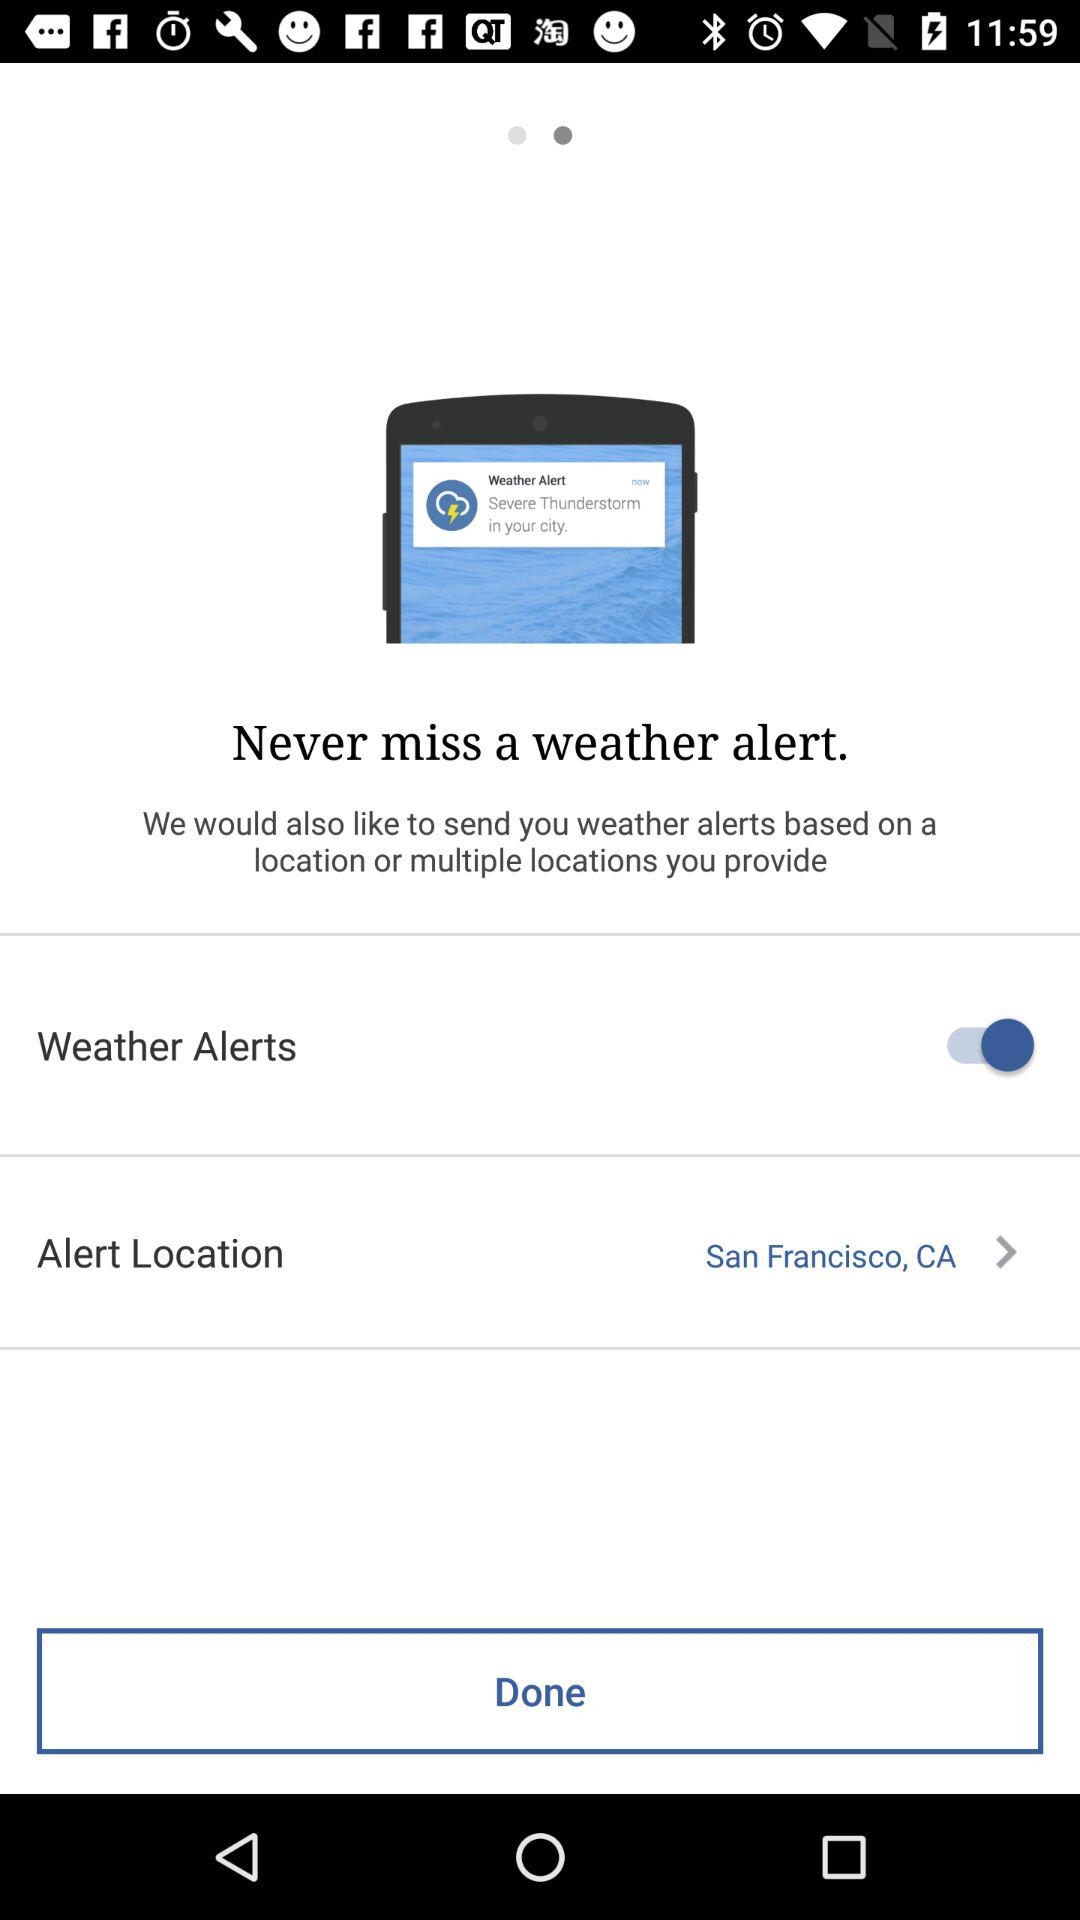What's the alert location? The alert location is San Francisco, CA. 